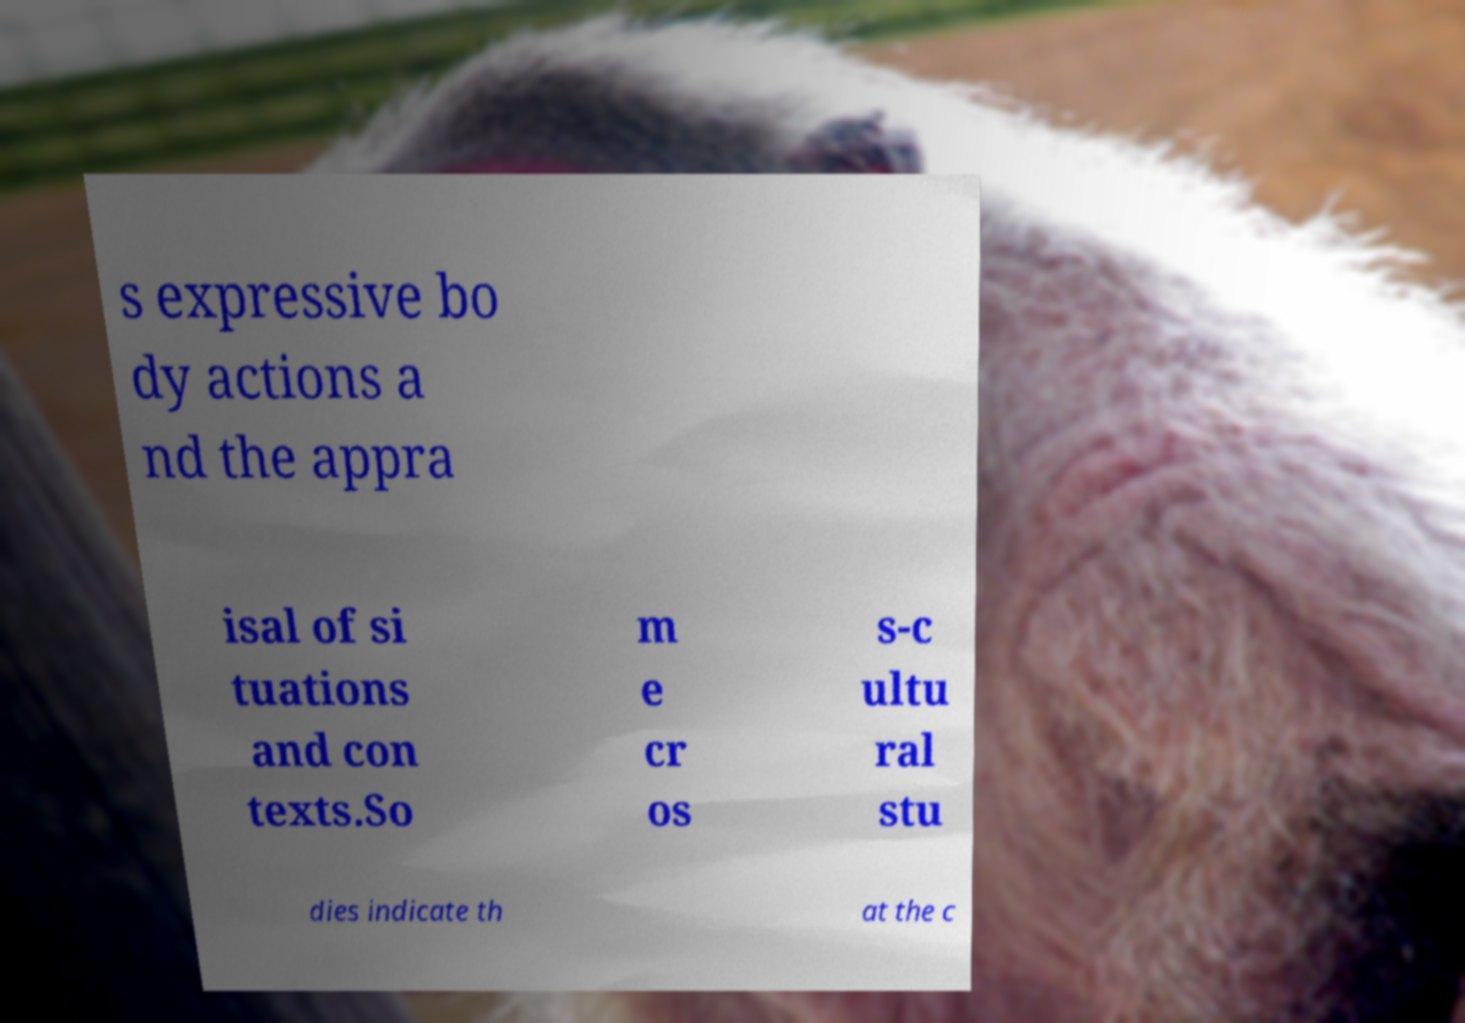What messages or text are displayed in this image? I need them in a readable, typed format. s expressive bo dy actions a nd the appra isal of si tuations and con texts.So m e cr os s-c ultu ral stu dies indicate th at the c 